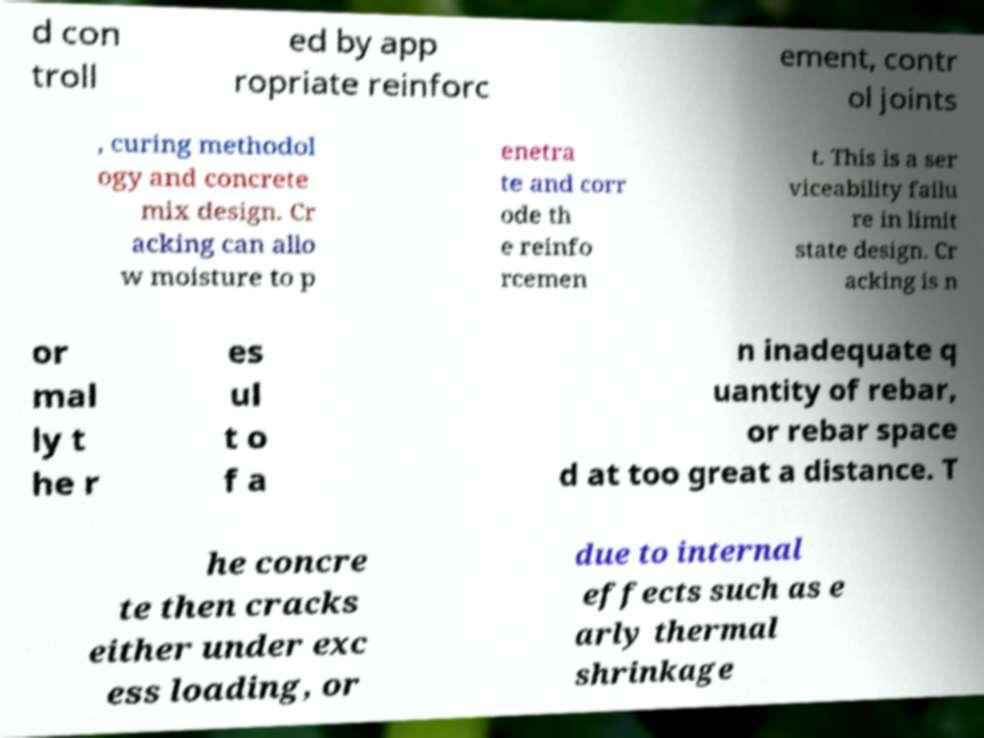What messages or text are displayed in this image? I need them in a readable, typed format. d con troll ed by app ropriate reinforc ement, contr ol joints , curing methodol ogy and concrete mix design. Cr acking can allo w moisture to p enetra te and corr ode th e reinfo rcemen t. This is a ser viceability failu re in limit state design. Cr acking is n or mal ly t he r es ul t o f a n inadequate q uantity of rebar, or rebar space d at too great a distance. T he concre te then cracks either under exc ess loading, or due to internal effects such as e arly thermal shrinkage 